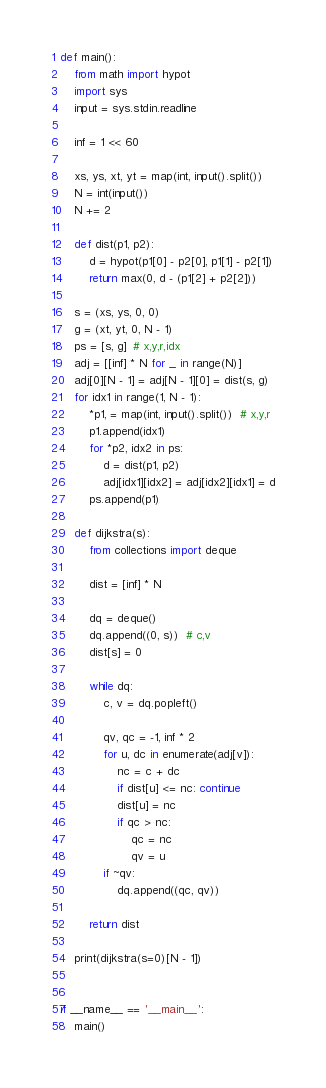Convert code to text. <code><loc_0><loc_0><loc_500><loc_500><_Python_>def main():
    from math import hypot
    import sys
    input = sys.stdin.readline

    inf = 1 << 60

    xs, ys, xt, yt = map(int, input().split())
    N = int(input())
    N += 2

    def dist(p1, p2):
        d = hypot(p1[0] - p2[0], p1[1] - p2[1])
        return max(0, d - (p1[2] + p2[2]))

    s = (xs, ys, 0, 0)
    g = (xt, yt, 0, N - 1)
    ps = [s, g]  # x,y,r,idx
    adj = [[inf] * N for _ in range(N)]
    adj[0][N - 1] = adj[N - 1][0] = dist(s, g)
    for idx1 in range(1, N - 1):
        *p1, = map(int, input().split())  # x,y,r
        p1.append(idx1)
        for *p2, idx2 in ps:
            d = dist(p1, p2)
            adj[idx1][idx2] = adj[idx2][idx1] = d
        ps.append(p1)

    def dijkstra(s):
        from collections import deque

        dist = [inf] * N

        dq = deque()
        dq.append((0, s))  # c,v
        dist[s] = 0

        while dq:
            c, v = dq.popleft()

            qv, qc = -1, inf * 2
            for u, dc in enumerate(adj[v]):
                nc = c + dc
                if dist[u] <= nc: continue
                dist[u] = nc
                if qc > nc:
                    qc = nc
                    qv = u
            if ~qv:
                dq.append((qc, qv))

        return dist

    print(dijkstra(s=0)[N - 1])


if __name__ == '__main__':
    main()
</code> 